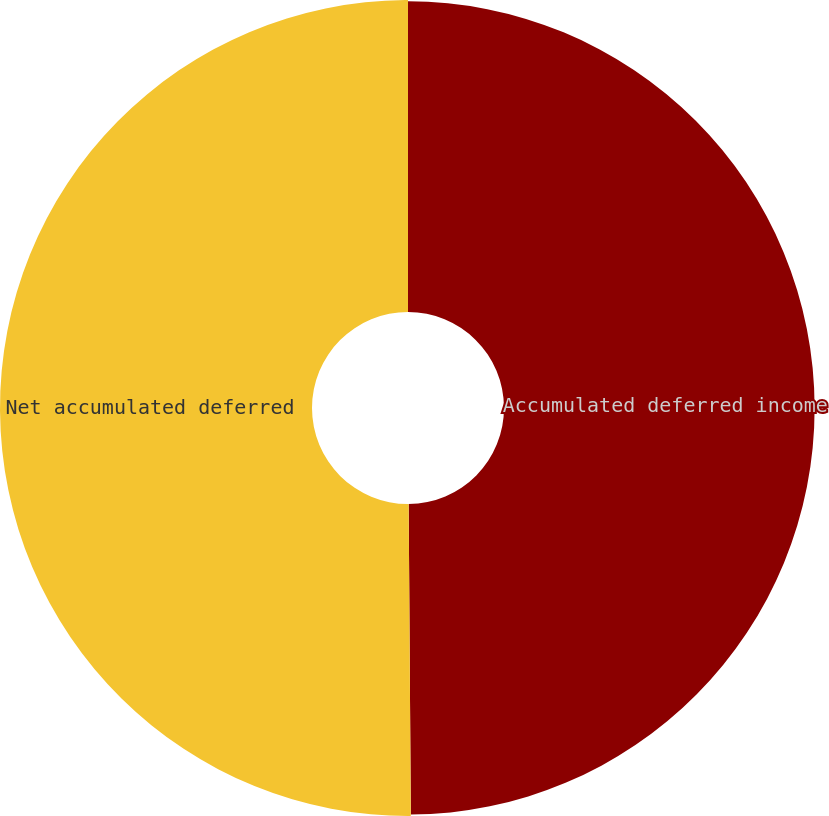Convert chart to OTSL. <chart><loc_0><loc_0><loc_500><loc_500><pie_chart><fcel>Accumulated deferred income<fcel>Net accumulated deferred<nl><fcel>49.89%<fcel>50.11%<nl></chart> 